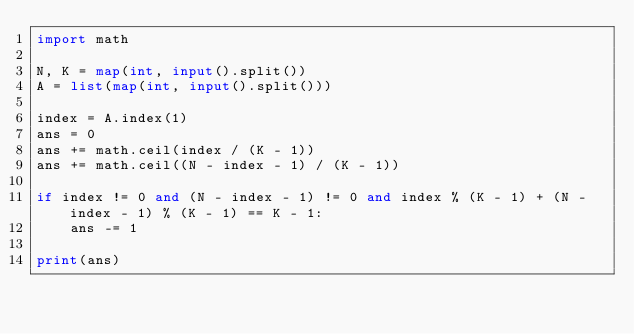Convert code to text. <code><loc_0><loc_0><loc_500><loc_500><_Python_>import math

N, K = map(int, input().split())
A = list(map(int, input().split()))

index = A.index(1)
ans = 0
ans += math.ceil(index / (K - 1))
ans += math.ceil((N - index - 1) / (K - 1))

if index != 0 and (N - index - 1) != 0 and index % (K - 1) + (N - index - 1) % (K - 1) == K - 1:
    ans -= 1

print(ans)</code> 